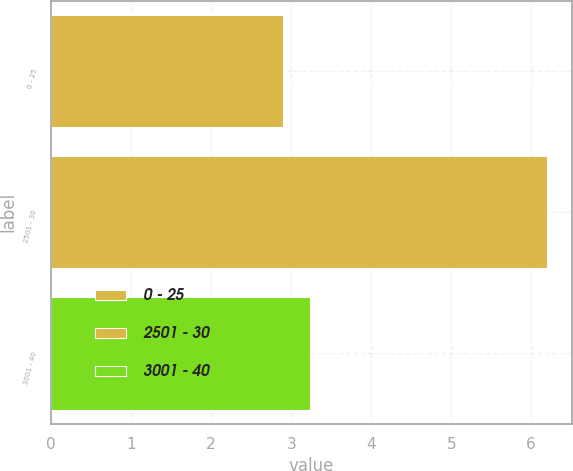<chart> <loc_0><loc_0><loc_500><loc_500><bar_chart><fcel>0 - 25<fcel>2501 - 30<fcel>3001 - 40<nl><fcel>2.9<fcel>6.2<fcel>3.23<nl></chart> 